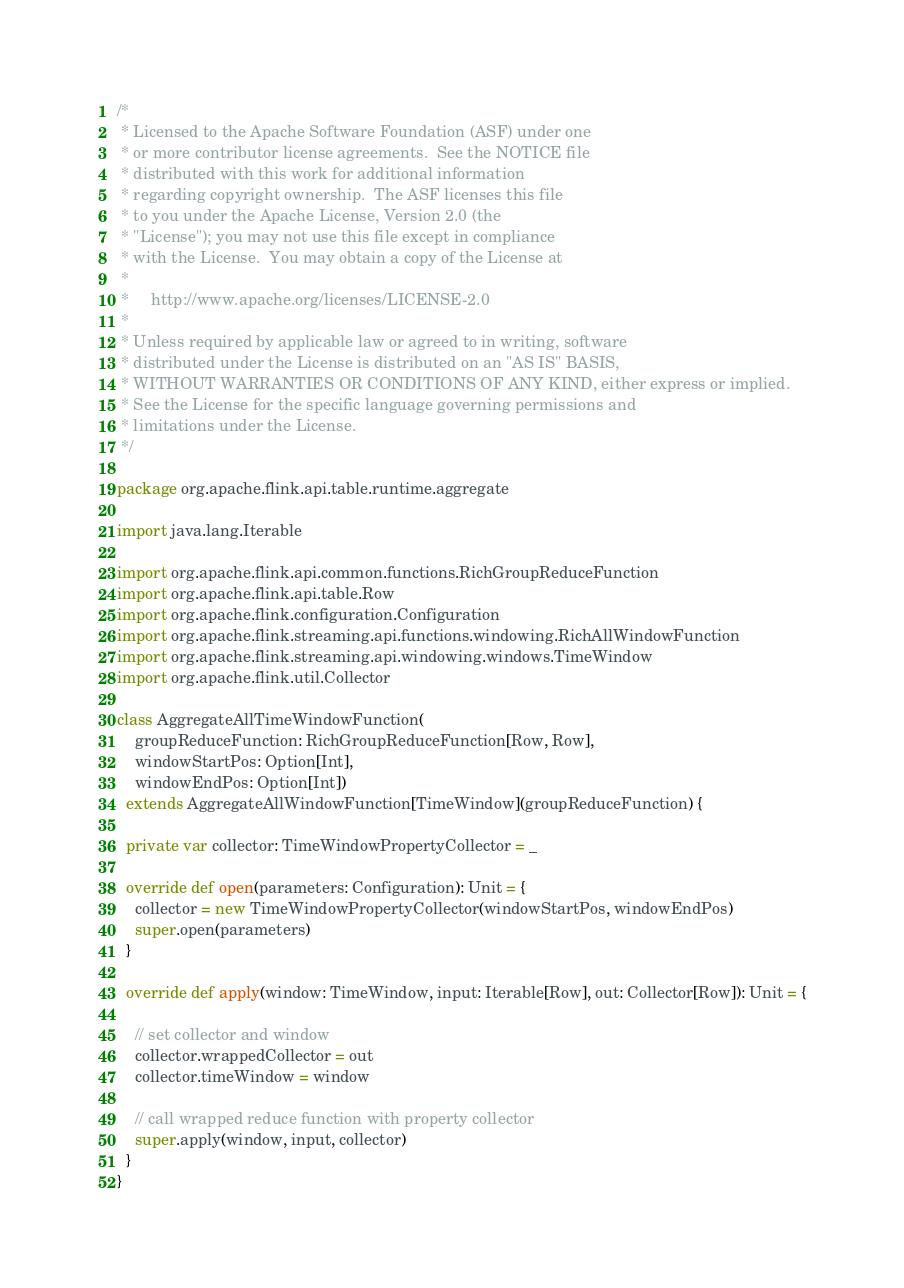<code> <loc_0><loc_0><loc_500><loc_500><_Scala_>/*
 * Licensed to the Apache Software Foundation (ASF) under one
 * or more contributor license agreements.  See the NOTICE file
 * distributed with this work for additional information
 * regarding copyright ownership.  The ASF licenses this file
 * to you under the Apache License, Version 2.0 (the
 * "License"); you may not use this file except in compliance
 * with the License.  You may obtain a copy of the License at
 *
 *     http://www.apache.org/licenses/LICENSE-2.0
 *
 * Unless required by applicable law or agreed to in writing, software
 * distributed under the License is distributed on an "AS IS" BASIS,
 * WITHOUT WARRANTIES OR CONDITIONS OF ANY KIND, either express or implied.
 * See the License for the specific language governing permissions and
 * limitations under the License.
 */

package org.apache.flink.api.table.runtime.aggregate

import java.lang.Iterable

import org.apache.flink.api.common.functions.RichGroupReduceFunction
import org.apache.flink.api.table.Row
import org.apache.flink.configuration.Configuration
import org.apache.flink.streaming.api.functions.windowing.RichAllWindowFunction
import org.apache.flink.streaming.api.windowing.windows.TimeWindow
import org.apache.flink.util.Collector

class AggregateAllTimeWindowFunction(
    groupReduceFunction: RichGroupReduceFunction[Row, Row],
    windowStartPos: Option[Int],
    windowEndPos: Option[Int])
  extends AggregateAllWindowFunction[TimeWindow](groupReduceFunction) {

  private var collector: TimeWindowPropertyCollector = _

  override def open(parameters: Configuration): Unit = {
    collector = new TimeWindowPropertyCollector(windowStartPos, windowEndPos)
    super.open(parameters)
  }

  override def apply(window: TimeWindow, input: Iterable[Row], out: Collector[Row]): Unit = {

    // set collector and window
    collector.wrappedCollector = out
    collector.timeWindow = window

    // call wrapped reduce function with property collector
    super.apply(window, input, collector)
  }
}
</code> 